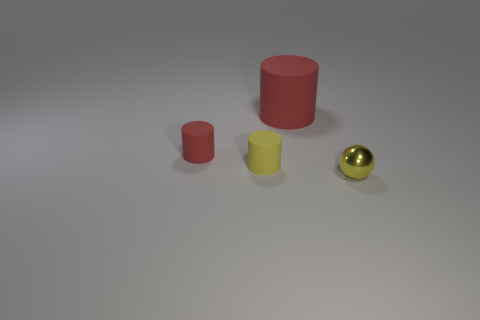What number of big red rubber cylinders are in front of the small red rubber cylinder?
Provide a succinct answer. 0. Is the number of big objects greater than the number of small gray shiny cylinders?
Offer a terse response. Yes. The other thing that is the same color as the metallic thing is what size?
Provide a short and direct response. Small. How big is the thing that is to the right of the yellow rubber thing and in front of the tiny red thing?
Provide a short and direct response. Small. There is a red cylinder left of the red thing that is on the right side of the red matte object left of the yellow matte cylinder; what is its material?
Ensure brevity in your answer.  Rubber. There is a cylinder that is the same color as the large thing; what material is it?
Provide a short and direct response. Rubber. There is a cylinder on the left side of the tiny yellow rubber cylinder; is it the same color as the tiny ball in front of the tiny yellow matte cylinder?
Give a very brief answer. No. The small yellow object in front of the small yellow thing behind the tiny thing that is on the right side of the big object is what shape?
Ensure brevity in your answer.  Sphere. What is the shape of the thing that is both right of the tiny yellow cylinder and behind the tiny metal sphere?
Your answer should be compact. Cylinder. How many shiny balls are to the right of the tiny yellow object that is right of the yellow thing behind the yellow ball?
Offer a terse response. 0. 